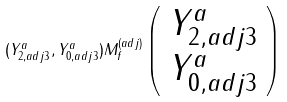Convert formula to latex. <formula><loc_0><loc_0><loc_500><loc_500>( Y ^ { a } _ { 2 , a d j 3 } , Y ^ { a } _ { 0 , a d j 3 } ) M _ { f } ^ { ( a d j ) } \left ( \begin{array} { c } Y ^ { a } _ { 2 , a d j 3 } \\ Y ^ { a } _ { 0 , a d j 3 } \end{array} \right )</formula> 